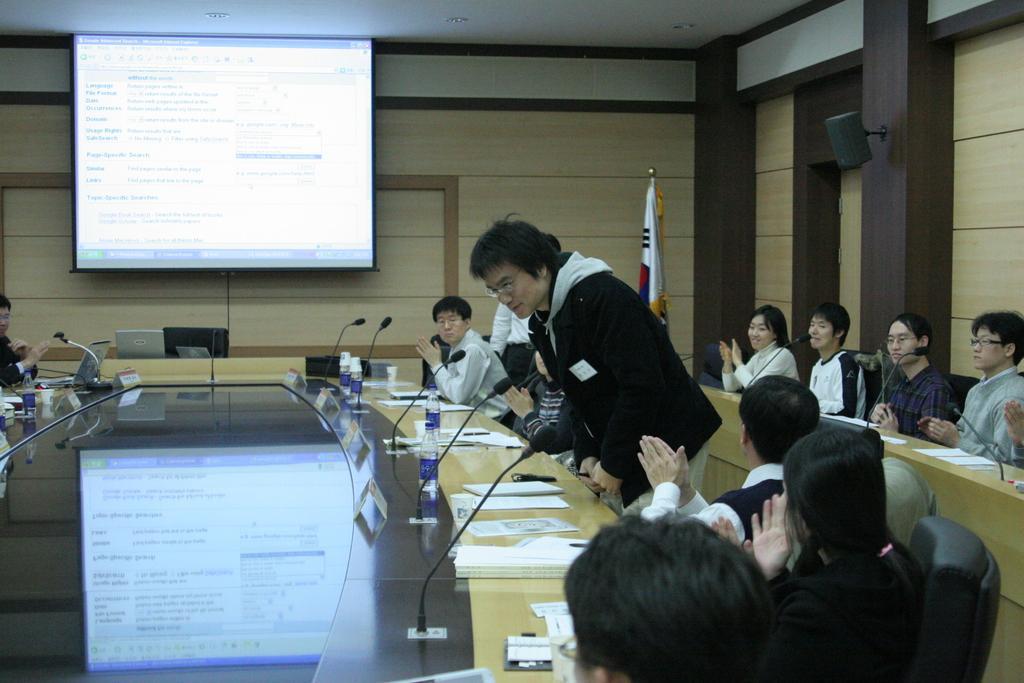Please provide a concise description of this image. In this image people are sitting on chairs, in front of them there is a table, on that table there are papers, water bottles and mics, in the background there is a wooden wall and there is a screen. 